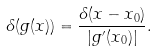Convert formula to latex. <formula><loc_0><loc_0><loc_500><loc_500>\delta ( g ( x ) ) = { \frac { \delta ( x - x _ { 0 } ) } { | g ^ { \prime } ( x _ { 0 } ) | } } .</formula> 